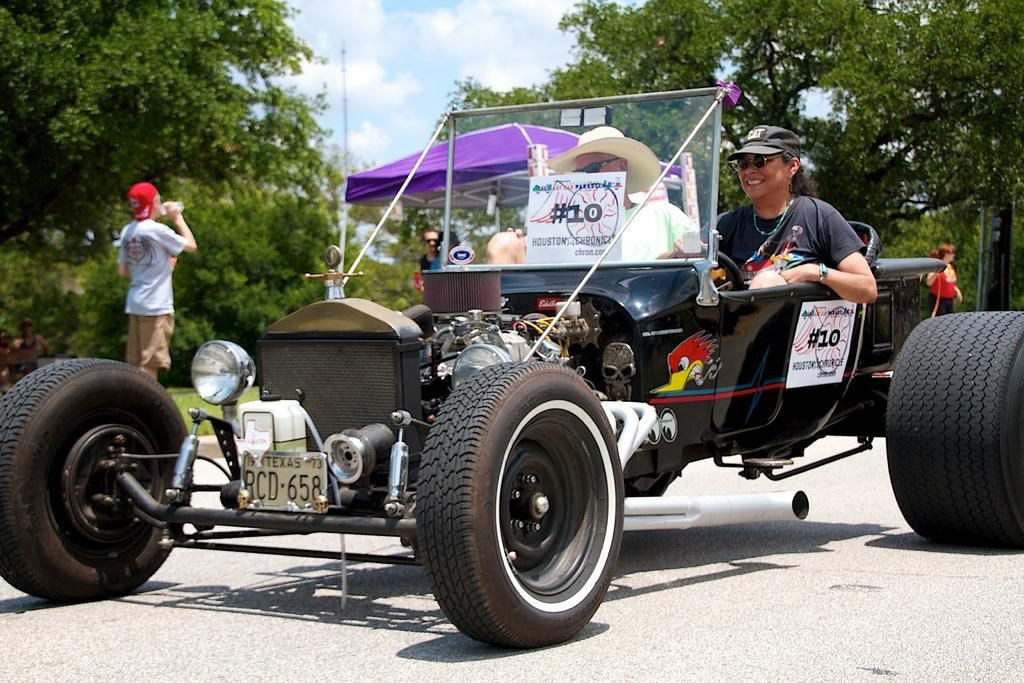How many people are in the image? There are two people in the image. What are the two people doing in the image? The two people are riding a four-wheeler. Where is the four-wheeler located? The four-wheeler is on a road. What can be seen in the background of the image? There is a tent and trees visible in the background. Can you show me the receipt for the four-wheeler in the image? There is no receipt present in the image; it is a photograph of two people riding a four-wheeler on a road. 